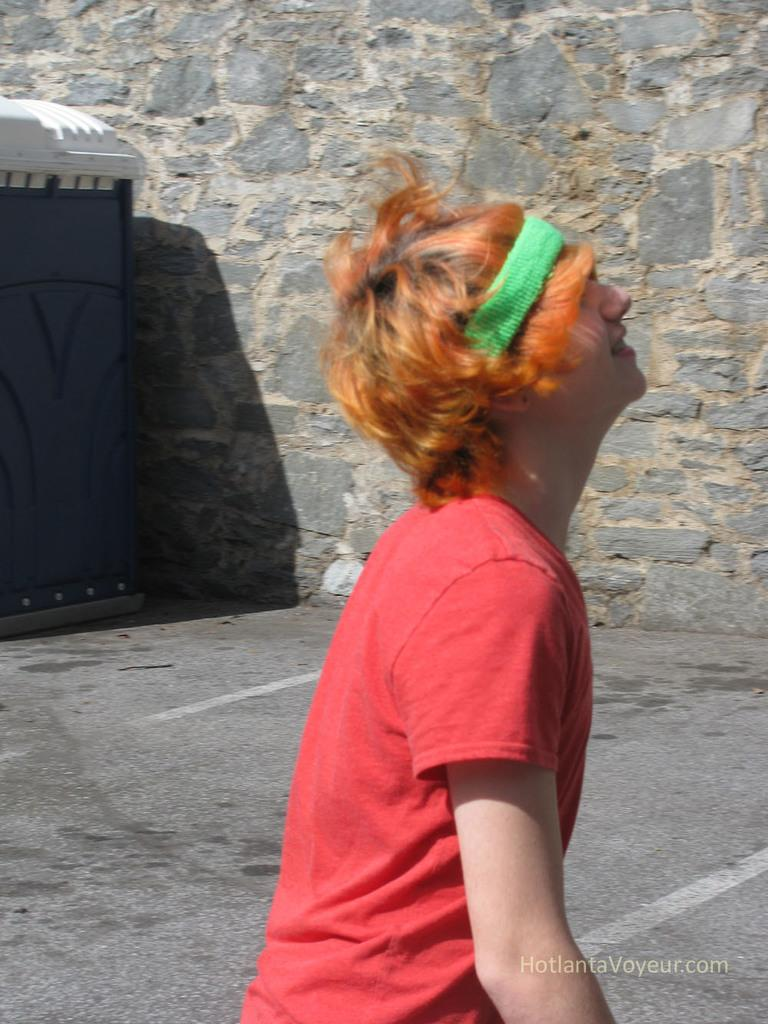What is the person in the image wearing? The person in the image is wearing a red t-shirt. What structure can be seen on the left side of the image? There is a cabin on the left side of the image. What is visible in the background of the image? There is a wall visible in the background of the image. How many goldfish are swimming in the pond in the image? There is no pond or goldfish present in the image. What type of substance is covering the ground in the image? There is no substance covering the ground mentioned in the provided facts; the image only shows a person, a cabin, and a wall. 